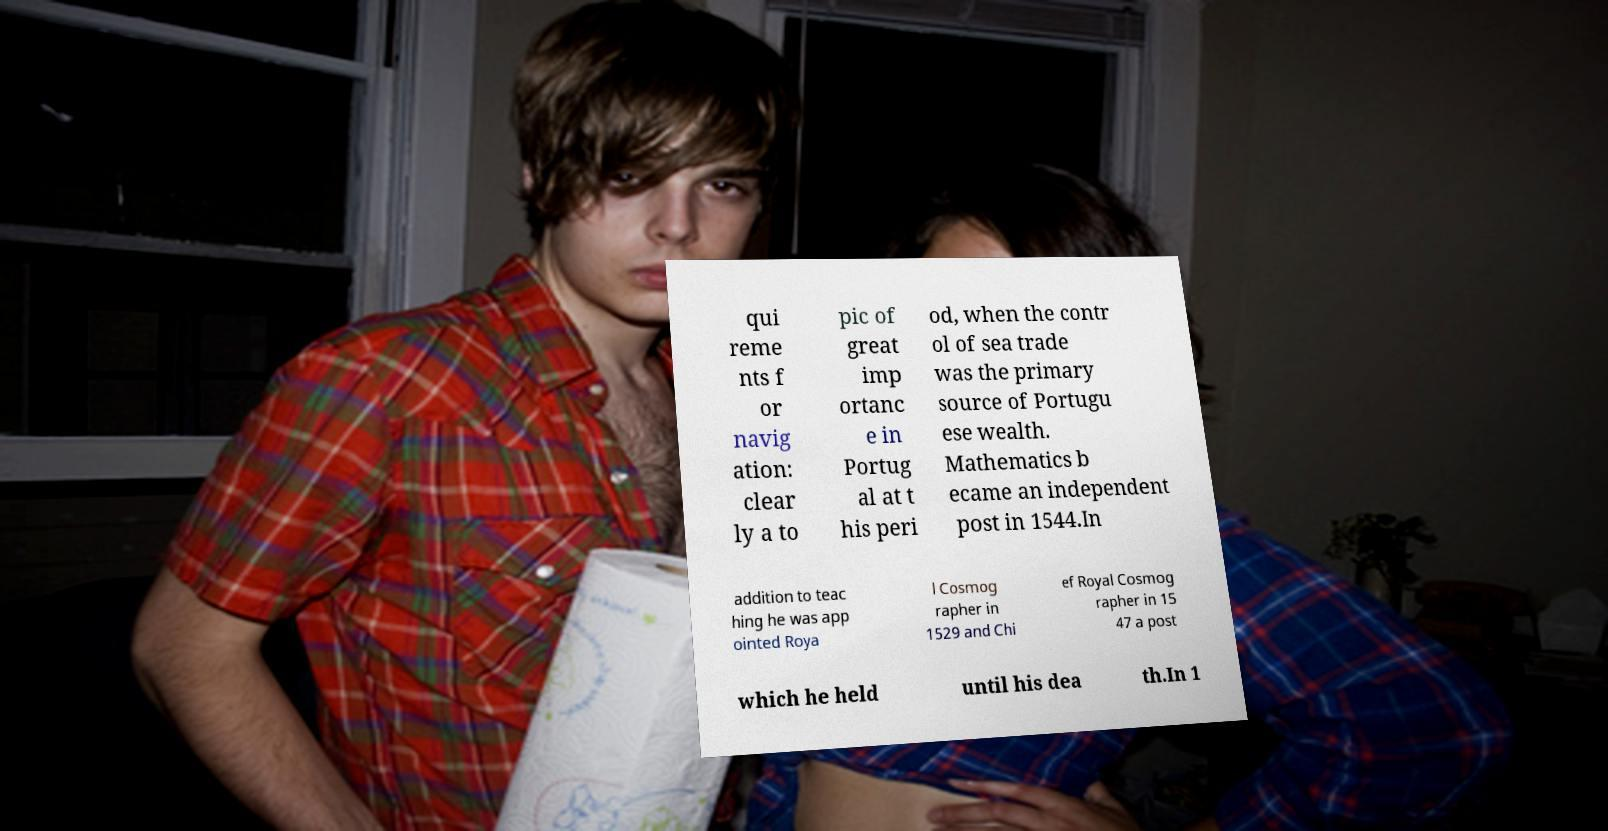Please read and relay the text visible in this image. What does it say? qui reme nts f or navig ation: clear ly a to pic of great imp ortanc e in Portug al at t his peri od, when the contr ol of sea trade was the primary source of Portugu ese wealth. Mathematics b ecame an independent post in 1544.In addition to teac hing he was app ointed Roya l Cosmog rapher in 1529 and Chi ef Royal Cosmog rapher in 15 47 a post which he held until his dea th.In 1 